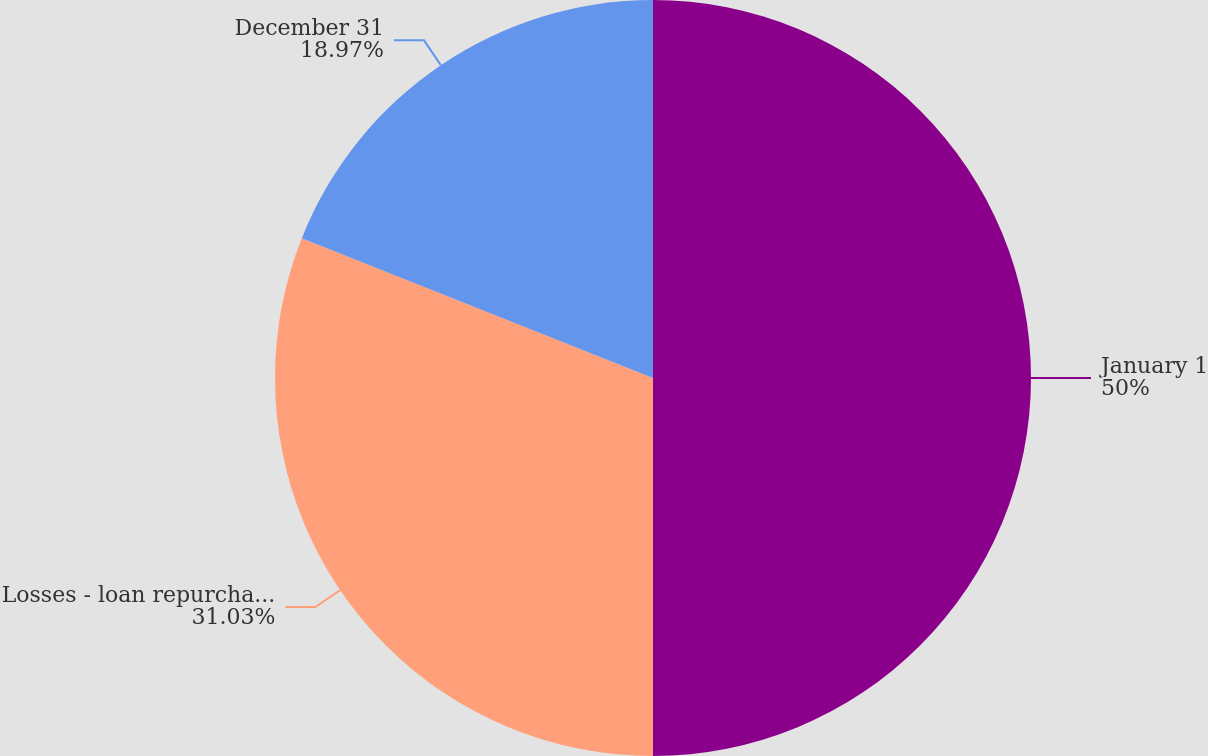<chart> <loc_0><loc_0><loc_500><loc_500><pie_chart><fcel>January 1<fcel>Losses - loan repurchases and<fcel>December 31<nl><fcel>50.0%<fcel>31.03%<fcel>18.97%<nl></chart> 